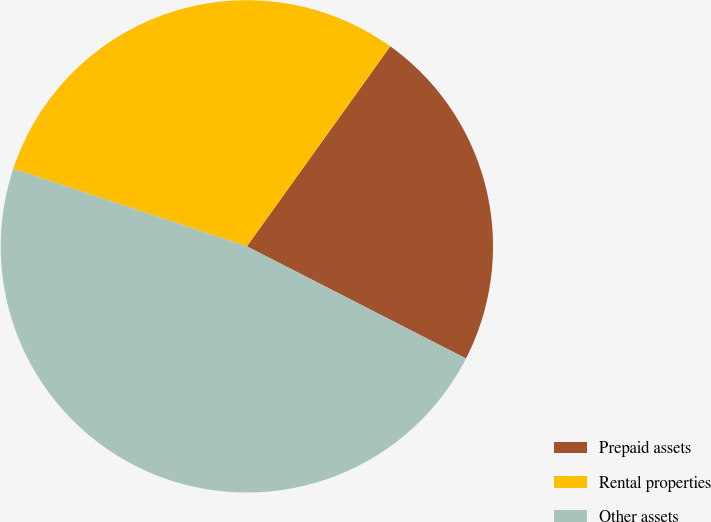Convert chart. <chart><loc_0><loc_0><loc_500><loc_500><pie_chart><fcel>Prepaid assets<fcel>Rental properties<fcel>Other assets<nl><fcel>22.63%<fcel>29.79%<fcel>47.58%<nl></chart> 